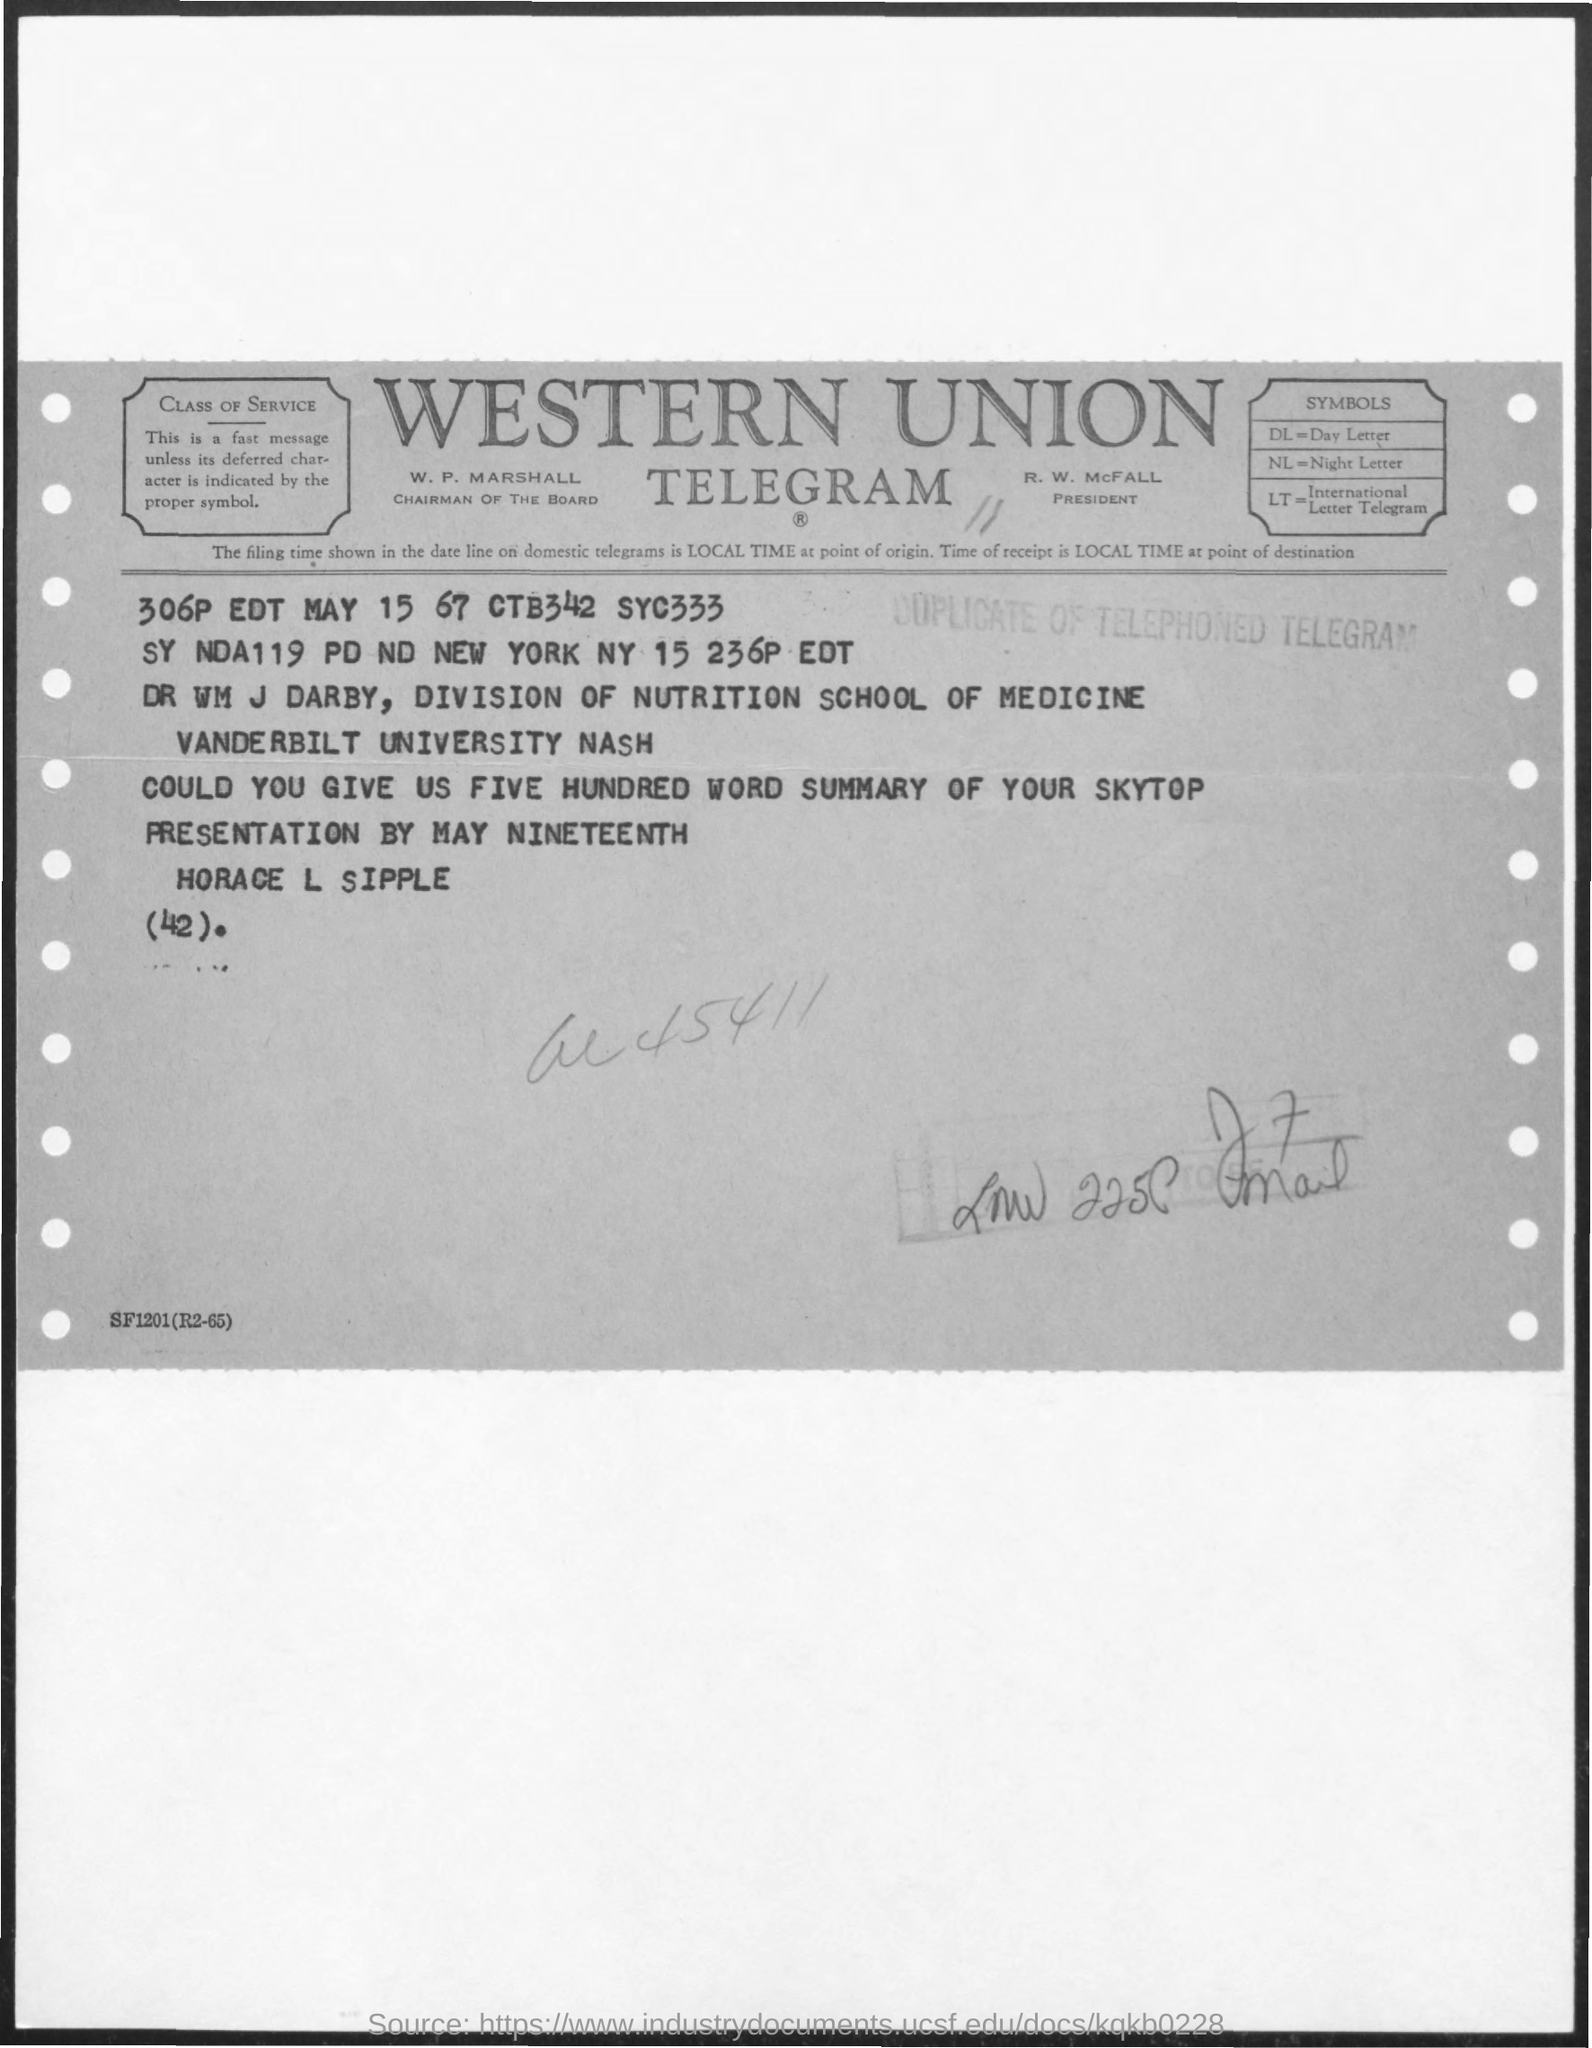What is the telegram name?
Your answer should be very brief. Western union. Who is the chairman of the board?
Your answer should be very brief. W. p. marshall. Who is the president?
Give a very brief answer. R. W. McFall. What does DL stand for?
Offer a terse response. Day Letter. What does nl stand for?
Offer a terse response. Night letter. What does LT stand for?
Give a very brief answer. International Letter Telegram. What is stamped on the document?
Make the answer very short. Duplicate of telephoned telegram. 